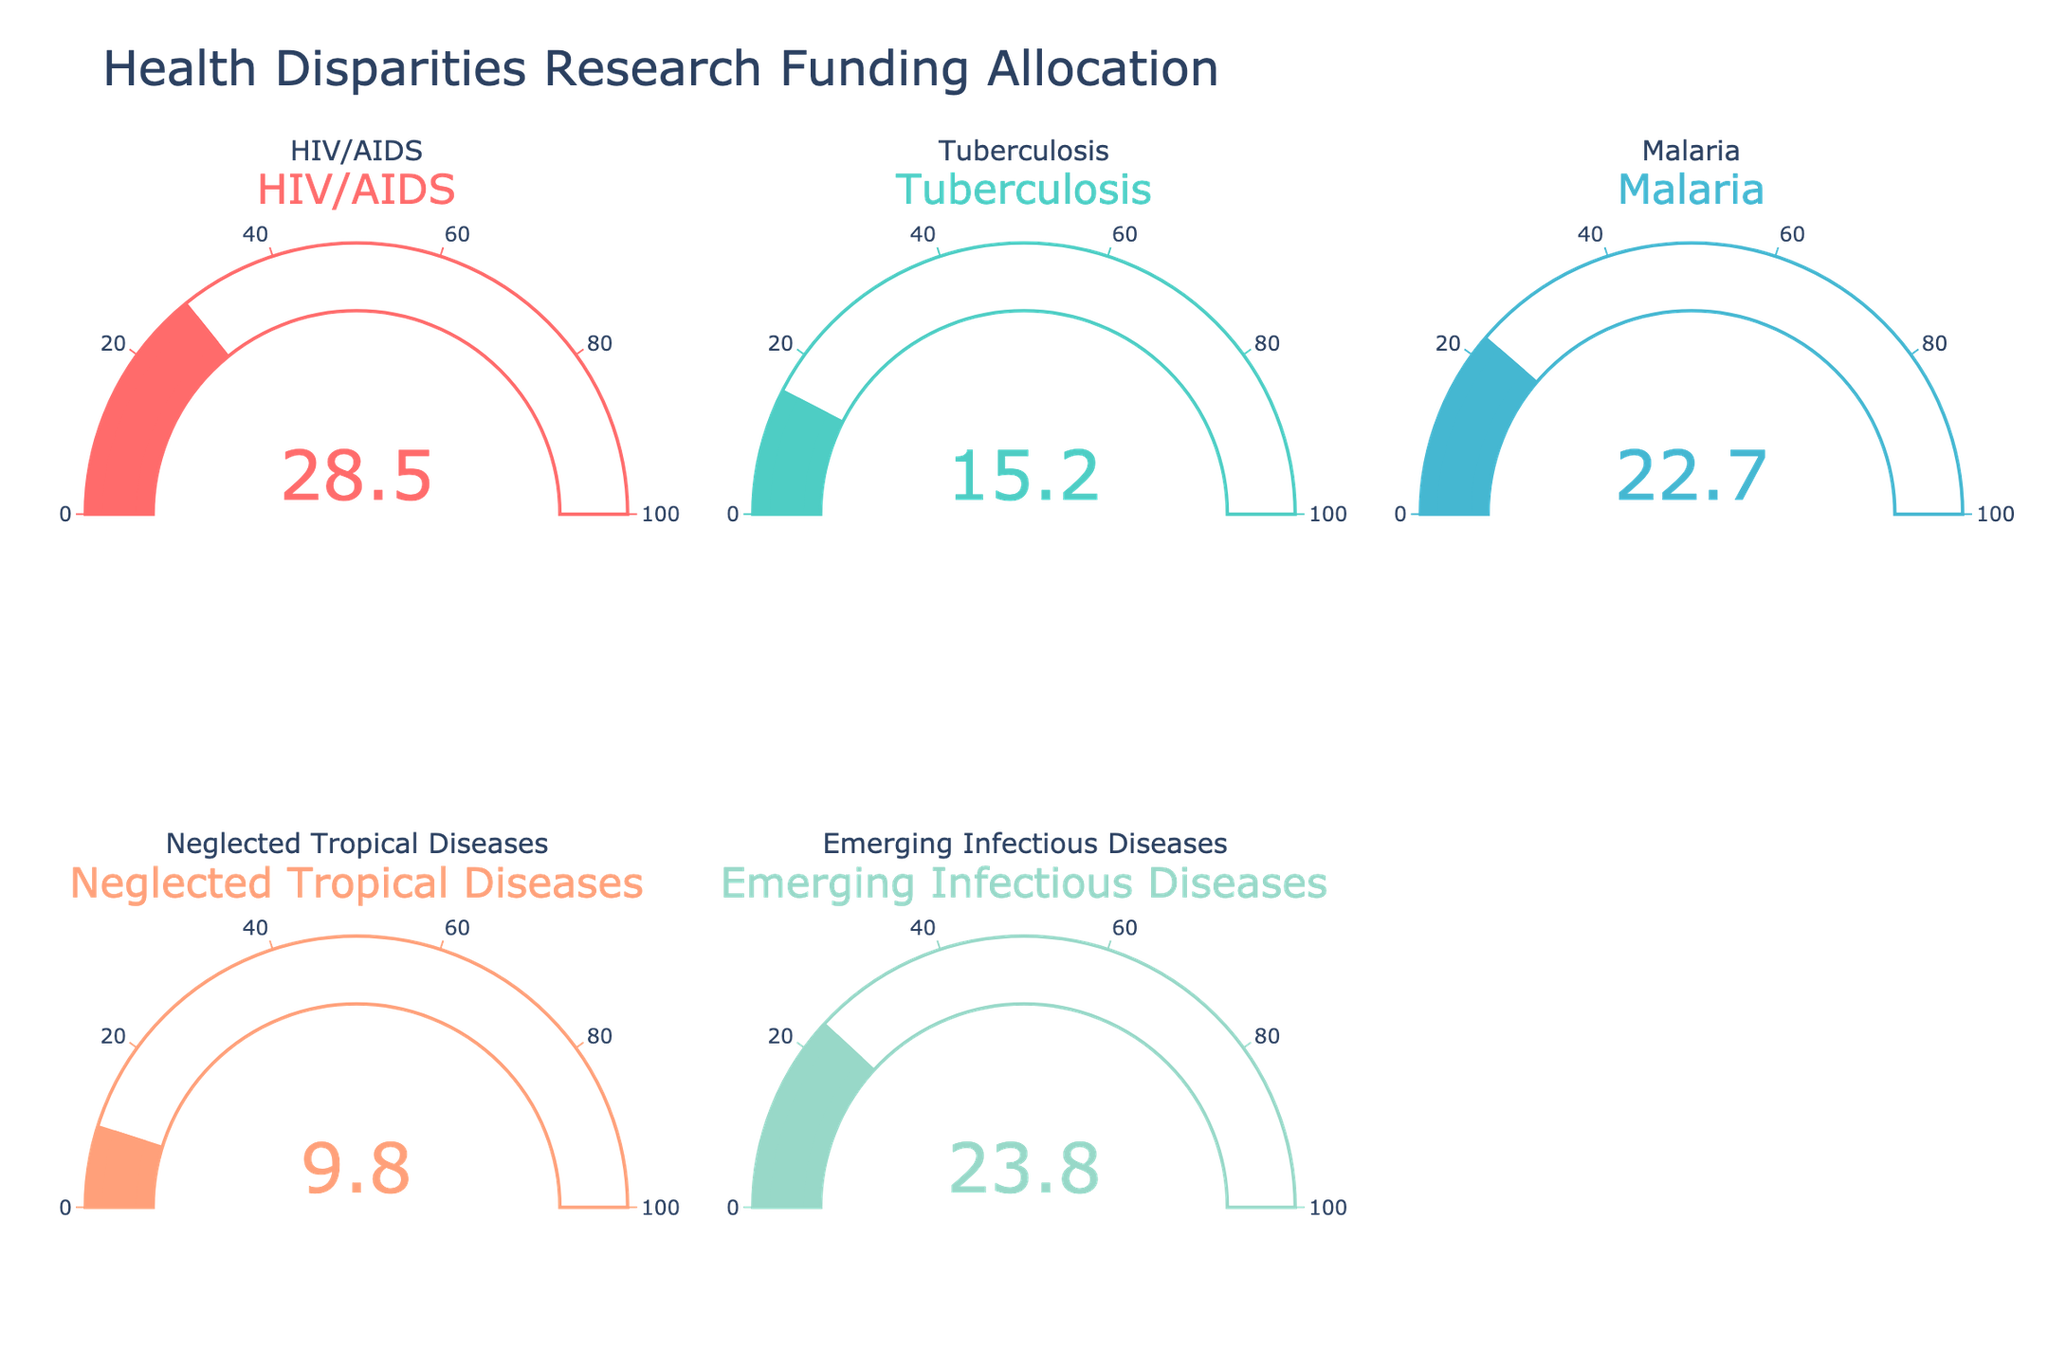What disease category has the highest percentage of research funding allocated? The gauge for HIV/AIDS shows the highest percentage, which is 28.5%.
Answer: HIV/AIDS What percentage of research funding is allocated to Neglected Tropical Diseases? The gauge specifically for Neglected Tropical Diseases indicates a value of 9.8%.
Answer: 9.8% Which disease category has the lowest percentage of research funding? The gauge for Neglected Tropical Diseases shows the lowest percentage at 9.8%.
Answer: Neglected Tropical Diseases How does the funding percentage for Malaria compare to that for Tuberculosis? The gauge for Malaria shows 22.7%, while Tuberculosis has 15.2%. Malaria receives more funding.
Answer: Malaria receives more funding What is the combined percentage of research funding for Emerging Infectious Diseases and HIV/AIDS? Emerging Infectious Diseases have 23.8% and HIV/AIDS has 28.5%. Summing these gives 23.8% + 28.5% = 52.3%.
Answer: 52.3% How much greater is the funding percentage for HIV/AIDS compared to Tuberculosis? HIV/AIDS has 28.5%, and Tuberculosis has 15.2%. The difference is 28.5% - 15.2% = 13.3%.
Answer: 13.3% Which categories receive more than 20% of the research funding? The gauges show that HIV/AIDS (28.5%), Malaria (22.7%), and Emerging Infectious Diseases (23.8%) each receive more than 20%.
Answer: HIV/AIDS, Malaria, and Emerging Infectious Diseases What is the average percentage of research funding across all categories? Sum all percentages (28.5 + 15.2 + 22.7 + 9.8 + 23.8) = 100. Then divide by 5, the number of categories: 100 / 5 = 20%.
Answer: 20% Which category has a funding percentage closest to the overall average? The average funding percentage is 20%. The closest categories are Malaria at 22.7% and Emerging Infectious Diseases at 23.8%, with Malaria being slightly closer.
Answer: Malaria 